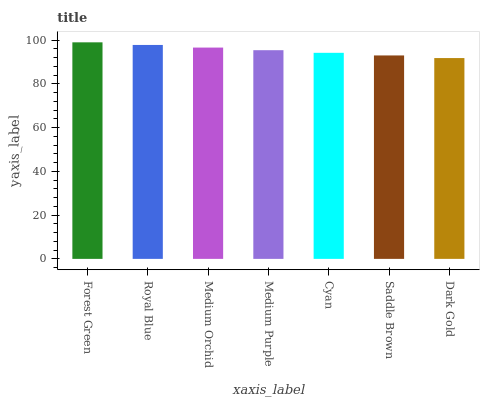Is Dark Gold the minimum?
Answer yes or no. Yes. Is Forest Green the maximum?
Answer yes or no. Yes. Is Royal Blue the minimum?
Answer yes or no. No. Is Royal Blue the maximum?
Answer yes or no. No. Is Forest Green greater than Royal Blue?
Answer yes or no. Yes. Is Royal Blue less than Forest Green?
Answer yes or no. Yes. Is Royal Blue greater than Forest Green?
Answer yes or no. No. Is Forest Green less than Royal Blue?
Answer yes or no. No. Is Medium Purple the high median?
Answer yes or no. Yes. Is Medium Purple the low median?
Answer yes or no. Yes. Is Medium Orchid the high median?
Answer yes or no. No. Is Cyan the low median?
Answer yes or no. No. 